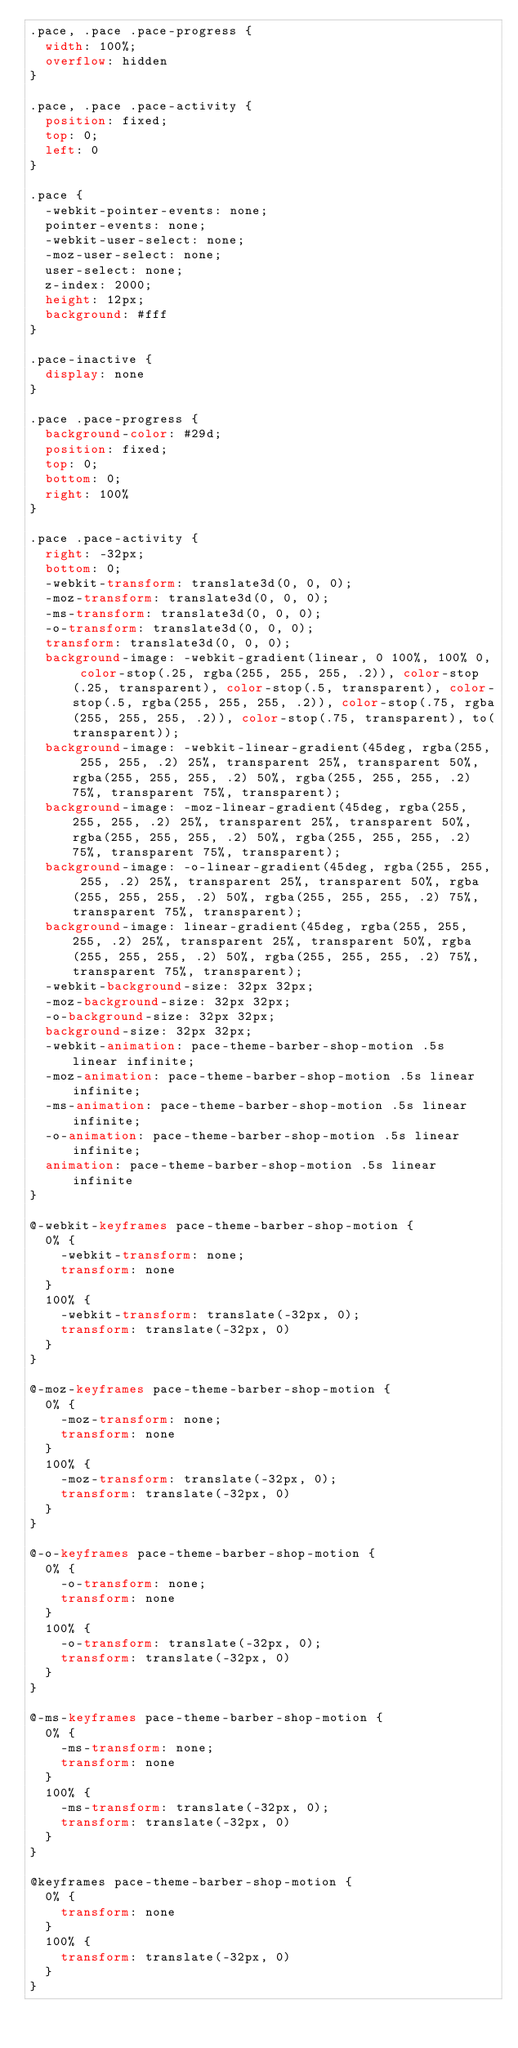<code> <loc_0><loc_0><loc_500><loc_500><_CSS_>.pace, .pace .pace-progress {
  width: 100%;
  overflow: hidden
}

.pace, .pace .pace-activity {
  position: fixed;
  top: 0;
  left: 0
}

.pace {
  -webkit-pointer-events: none;
  pointer-events: none;
  -webkit-user-select: none;
  -moz-user-select: none;
  user-select: none;
  z-index: 2000;
  height: 12px;
  background: #fff
}

.pace-inactive {
  display: none
}

.pace .pace-progress {
  background-color: #29d;
  position: fixed;
  top: 0;
  bottom: 0;
  right: 100%
}

.pace .pace-activity {
  right: -32px;
  bottom: 0;
  -webkit-transform: translate3d(0, 0, 0);
  -moz-transform: translate3d(0, 0, 0);
  -ms-transform: translate3d(0, 0, 0);
  -o-transform: translate3d(0, 0, 0);
  transform: translate3d(0, 0, 0);
  background-image: -webkit-gradient(linear, 0 100%, 100% 0, color-stop(.25, rgba(255, 255, 255, .2)), color-stop(.25, transparent), color-stop(.5, transparent), color-stop(.5, rgba(255, 255, 255, .2)), color-stop(.75, rgba(255, 255, 255, .2)), color-stop(.75, transparent), to(transparent));
  background-image: -webkit-linear-gradient(45deg, rgba(255, 255, 255, .2) 25%, transparent 25%, transparent 50%, rgba(255, 255, 255, .2) 50%, rgba(255, 255, 255, .2) 75%, transparent 75%, transparent);
  background-image: -moz-linear-gradient(45deg, rgba(255, 255, 255, .2) 25%, transparent 25%, transparent 50%, rgba(255, 255, 255, .2) 50%, rgba(255, 255, 255, .2) 75%, transparent 75%, transparent);
  background-image: -o-linear-gradient(45deg, rgba(255, 255, 255, .2) 25%, transparent 25%, transparent 50%, rgba(255, 255, 255, .2) 50%, rgba(255, 255, 255, .2) 75%, transparent 75%, transparent);
  background-image: linear-gradient(45deg, rgba(255, 255, 255, .2) 25%, transparent 25%, transparent 50%, rgba(255, 255, 255, .2) 50%, rgba(255, 255, 255, .2) 75%, transparent 75%, transparent);
  -webkit-background-size: 32px 32px;
  -moz-background-size: 32px 32px;
  -o-background-size: 32px 32px;
  background-size: 32px 32px;
  -webkit-animation: pace-theme-barber-shop-motion .5s linear infinite;
  -moz-animation: pace-theme-barber-shop-motion .5s linear infinite;
  -ms-animation: pace-theme-barber-shop-motion .5s linear infinite;
  -o-animation: pace-theme-barber-shop-motion .5s linear infinite;
  animation: pace-theme-barber-shop-motion .5s linear infinite
}

@-webkit-keyframes pace-theme-barber-shop-motion {
  0% {
    -webkit-transform: none;
    transform: none
  }
  100% {
    -webkit-transform: translate(-32px, 0);
    transform: translate(-32px, 0)
  }
}

@-moz-keyframes pace-theme-barber-shop-motion {
  0% {
    -moz-transform: none;
    transform: none
  }
  100% {
    -moz-transform: translate(-32px, 0);
    transform: translate(-32px, 0)
  }
}

@-o-keyframes pace-theme-barber-shop-motion {
  0% {
    -o-transform: none;
    transform: none
  }
  100% {
    -o-transform: translate(-32px, 0);
    transform: translate(-32px, 0)
  }
}

@-ms-keyframes pace-theme-barber-shop-motion {
  0% {
    -ms-transform: none;
    transform: none
  }
  100% {
    -ms-transform: translate(-32px, 0);
    transform: translate(-32px, 0)
  }
}

@keyframes pace-theme-barber-shop-motion {
  0% {
    transform: none
  }
  100% {
    transform: translate(-32px, 0)
  }
}
</code> 